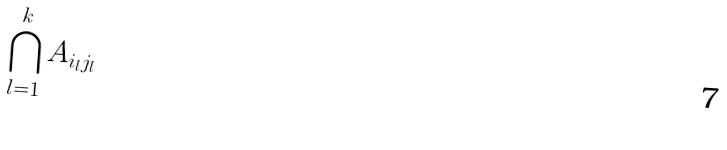Convert formula to latex. <formula><loc_0><loc_0><loc_500><loc_500>\bigcap _ { l = 1 } ^ { k } A _ { i _ { l } j _ { l } }</formula> 